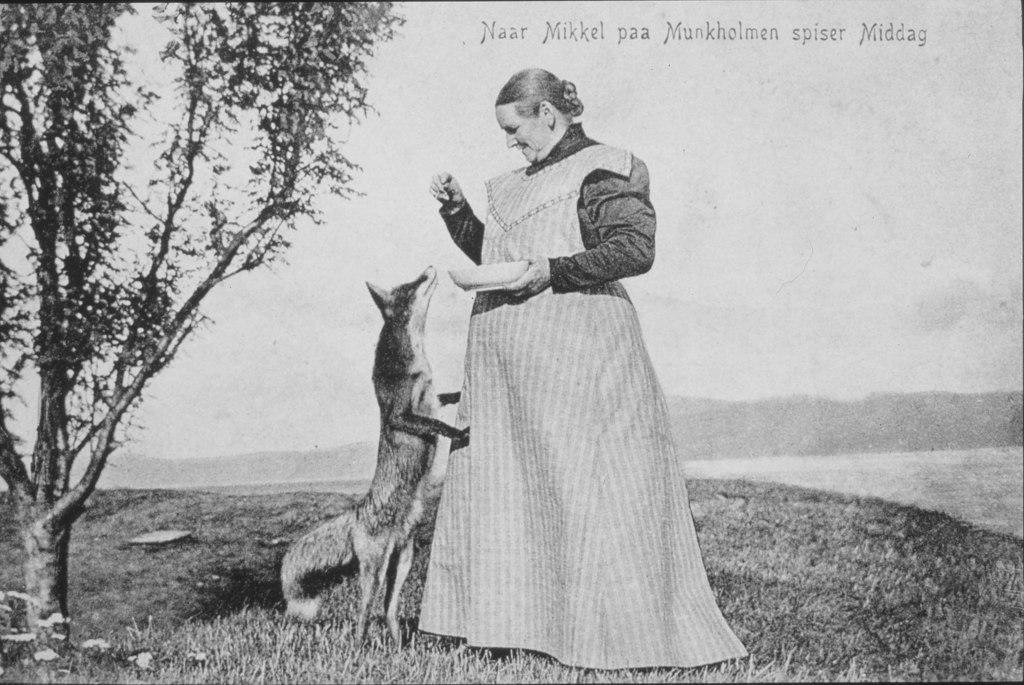In one or two sentences, can you explain what this image depicts? In this picture there is a woman standing and holding the bowl and there is an animal standing. On the left side of the image there is a tree. At the top there is sky. At the bottom there is water and there is grass. 